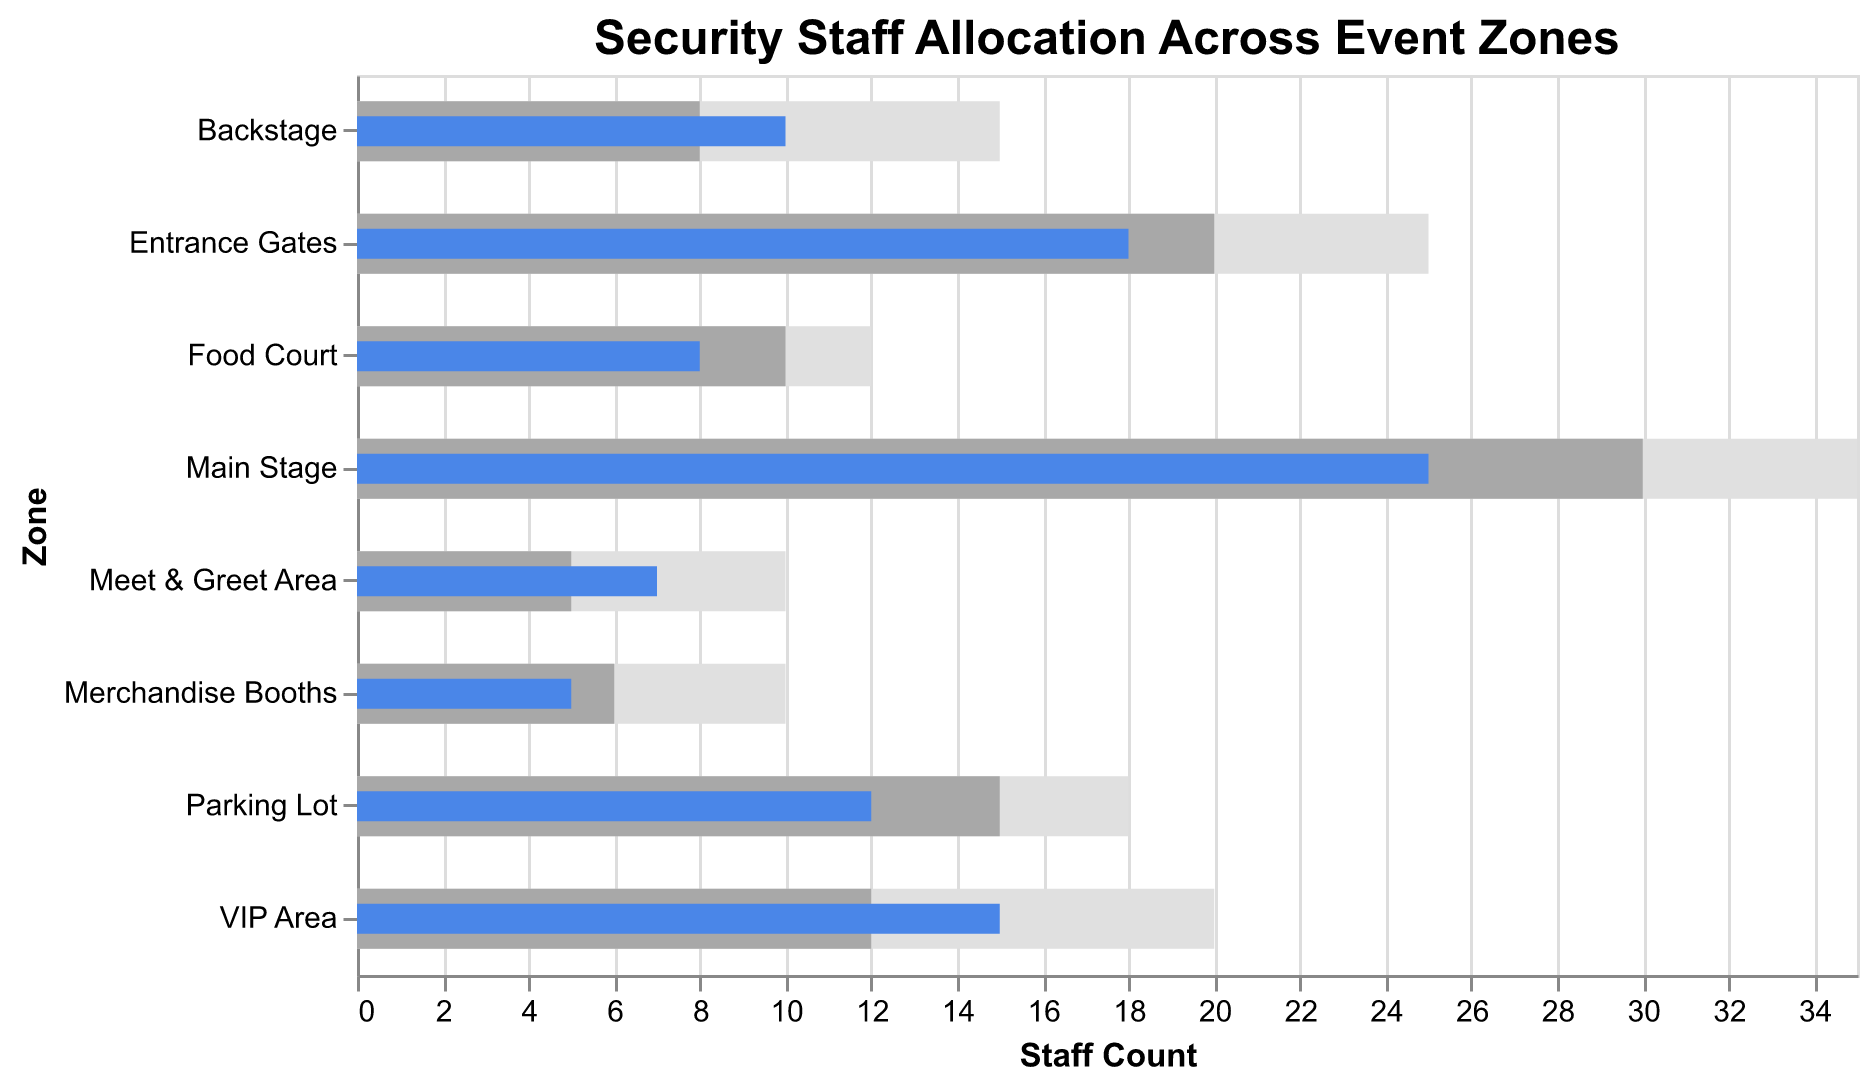What's the title of the bullet chart? The title is displayed at the top of the chart, written in bold Arial font and of a larger size compared to other text elements.
Answer: Security Staff Allocation Across Event Zones How many zones have the actual number of security staff less than the recommended number? Look at the blue bars (actual staff) and compare with the grey bars (recommended staff) for all zones. Count the zones where the blue bar is shorter.
Answer: 4 Which zone has the largest difference between actual and recommended staff levels? Calculate the difference (Recommended - Actual) for each zone and identify the largest value.
Answer: Main Stage In which zone is the actual number of security staff equal to the recommended number? Compare the length of the blue and grey bars for each zone and find where they match.
Answer: There is no such zone Are there any zones where the actual staff exceeds the maximum staff level? Compare the lengths of the blue bars (actual staff) with the light grey bars (maximum staff) to see if any blue bar is longer.
Answer: No What is the zone with the lowest actual security staff count? Identify the shortest blue bar which represents actual staff count.
Answer: Merchandise Booths Which zone has the actual staff count that most significantly exceeds the recommended level? Calculate the difference (Actual - Recommended) and identify the highest positive value.
Answer: VIP Area How many zones have an actual number of security staff greater than the recommended level? Compare the blue bars (actual staff) with the grey bars (recommended staff) and count the zones where the blue bar is longer.
Answer: 3 What is the difference in the actual number of security staff between the Entrance Gates and the Food Court? Subtract the blue bar value of the Food Court from that of the Entrance Gates (18 - 8).
Answer: 10 